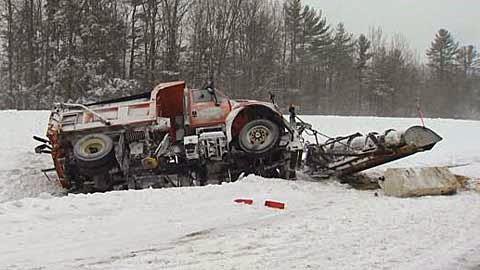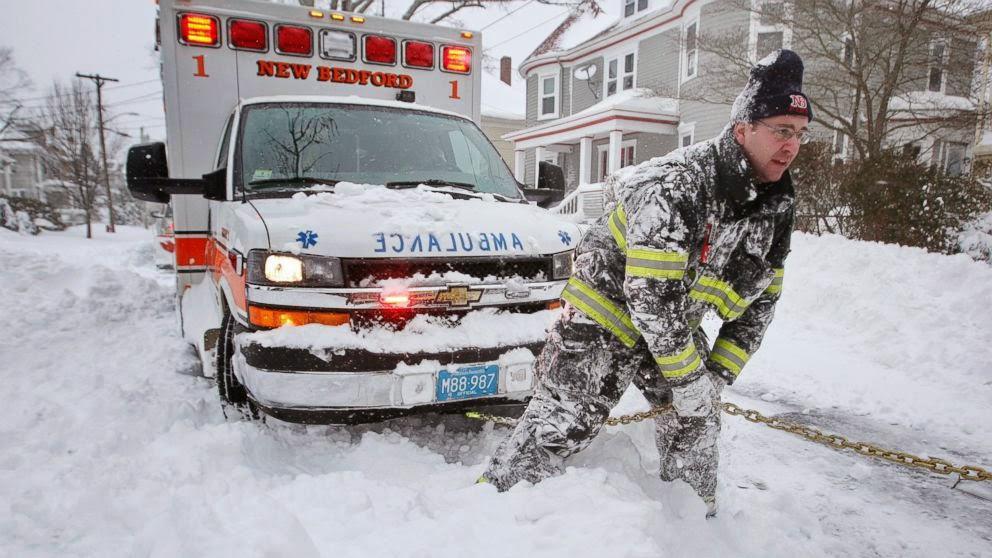The first image is the image on the left, the second image is the image on the right. Considering the images on both sides, is "An image shows more than one snowplow truck on the same snowy road." valid? Answer yes or no. No. 